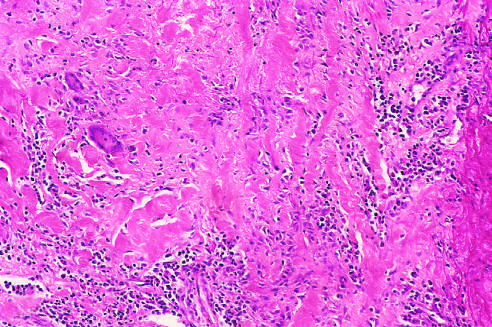what is associated with mononuclear infiltrates and giant cells?
Answer the question using a single word or phrase. Destruction and fibrosis of the arterial media 